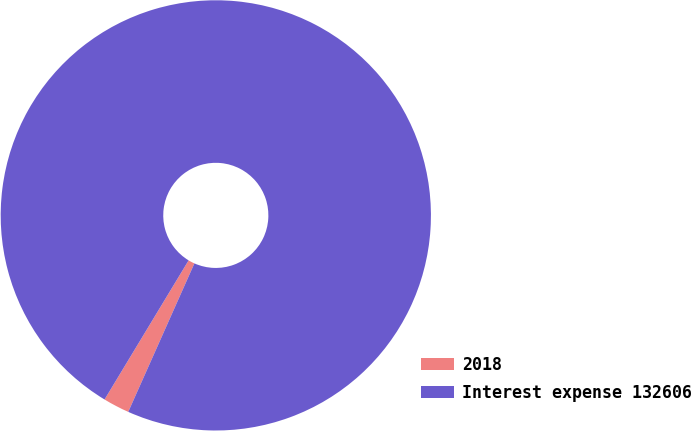Convert chart. <chart><loc_0><loc_0><loc_500><loc_500><pie_chart><fcel>2018<fcel>Interest expense 132606<nl><fcel>1.98%<fcel>98.02%<nl></chart> 